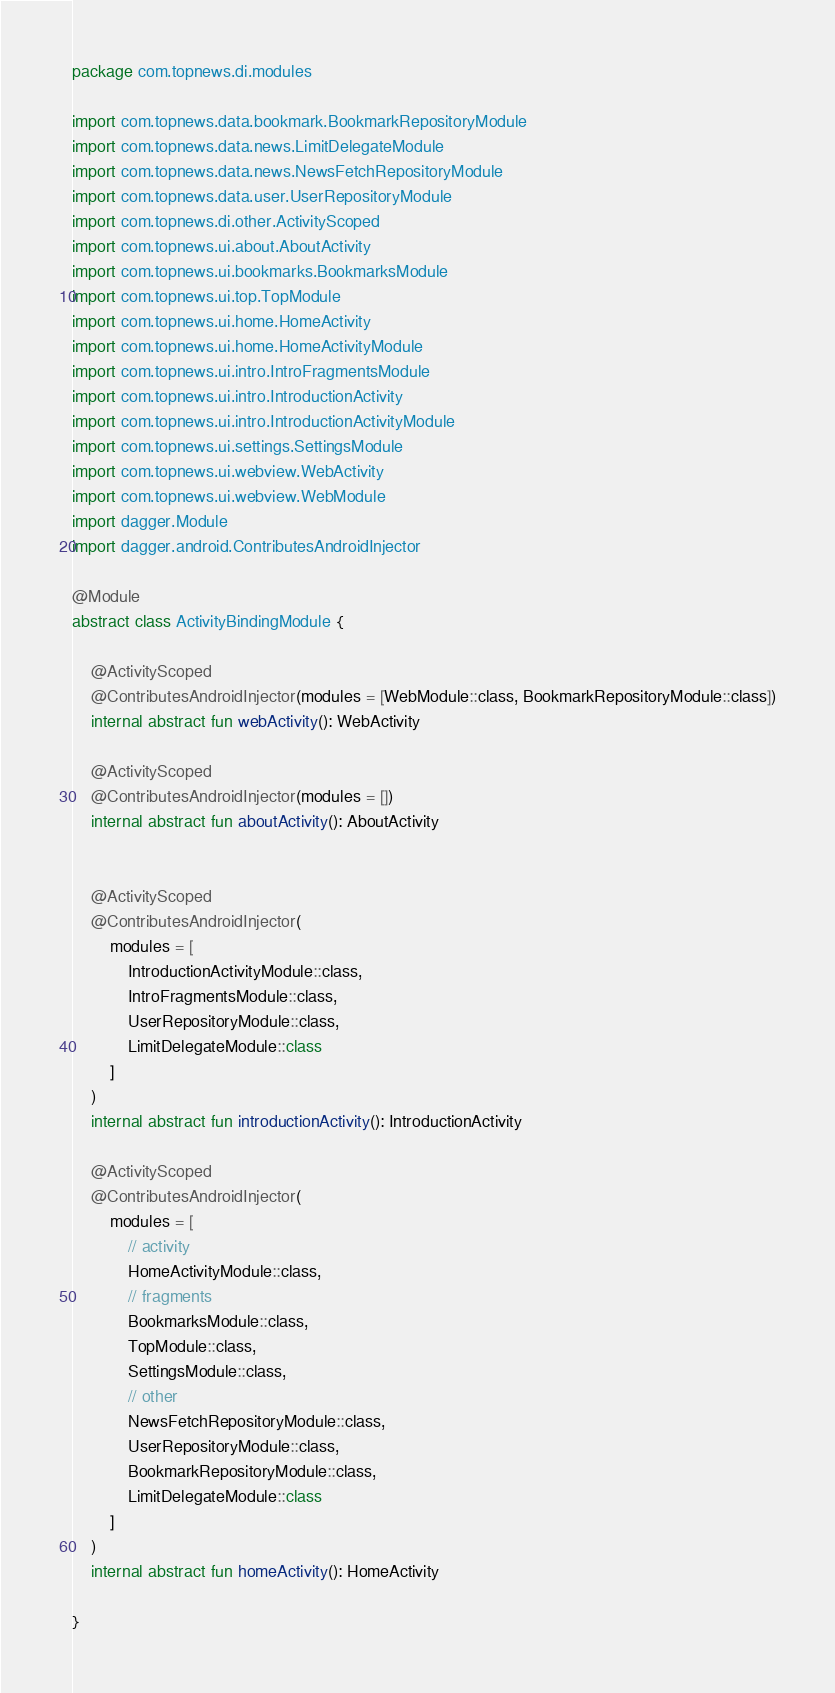<code> <loc_0><loc_0><loc_500><loc_500><_Kotlin_>package com.topnews.di.modules

import com.topnews.data.bookmark.BookmarkRepositoryModule
import com.topnews.data.news.LimitDelegateModule
import com.topnews.data.news.NewsFetchRepositoryModule
import com.topnews.data.user.UserRepositoryModule
import com.topnews.di.other.ActivityScoped
import com.topnews.ui.about.AboutActivity
import com.topnews.ui.bookmarks.BookmarksModule
import com.topnews.ui.top.TopModule
import com.topnews.ui.home.HomeActivity
import com.topnews.ui.home.HomeActivityModule
import com.topnews.ui.intro.IntroFragmentsModule
import com.topnews.ui.intro.IntroductionActivity
import com.topnews.ui.intro.IntroductionActivityModule
import com.topnews.ui.settings.SettingsModule
import com.topnews.ui.webview.WebActivity
import com.topnews.ui.webview.WebModule
import dagger.Module
import dagger.android.ContributesAndroidInjector

@Module
abstract class ActivityBindingModule {

    @ActivityScoped
    @ContributesAndroidInjector(modules = [WebModule::class, BookmarkRepositoryModule::class])
    internal abstract fun webActivity(): WebActivity

    @ActivityScoped
    @ContributesAndroidInjector(modules = [])
    internal abstract fun aboutActivity(): AboutActivity


    @ActivityScoped
    @ContributesAndroidInjector(
        modules = [
            IntroductionActivityModule::class,
            IntroFragmentsModule::class,
            UserRepositoryModule::class,
            LimitDelegateModule::class
        ]
    )
    internal abstract fun introductionActivity(): IntroductionActivity

    @ActivityScoped
    @ContributesAndroidInjector(
        modules = [
            // activity
            HomeActivityModule::class,
            // fragments
            BookmarksModule::class,
            TopModule::class,
            SettingsModule::class,
            // other
            NewsFetchRepositoryModule::class,
            UserRepositoryModule::class,
            BookmarkRepositoryModule::class,
            LimitDelegateModule::class
        ]
    )
    internal abstract fun homeActivity(): HomeActivity

}

</code> 